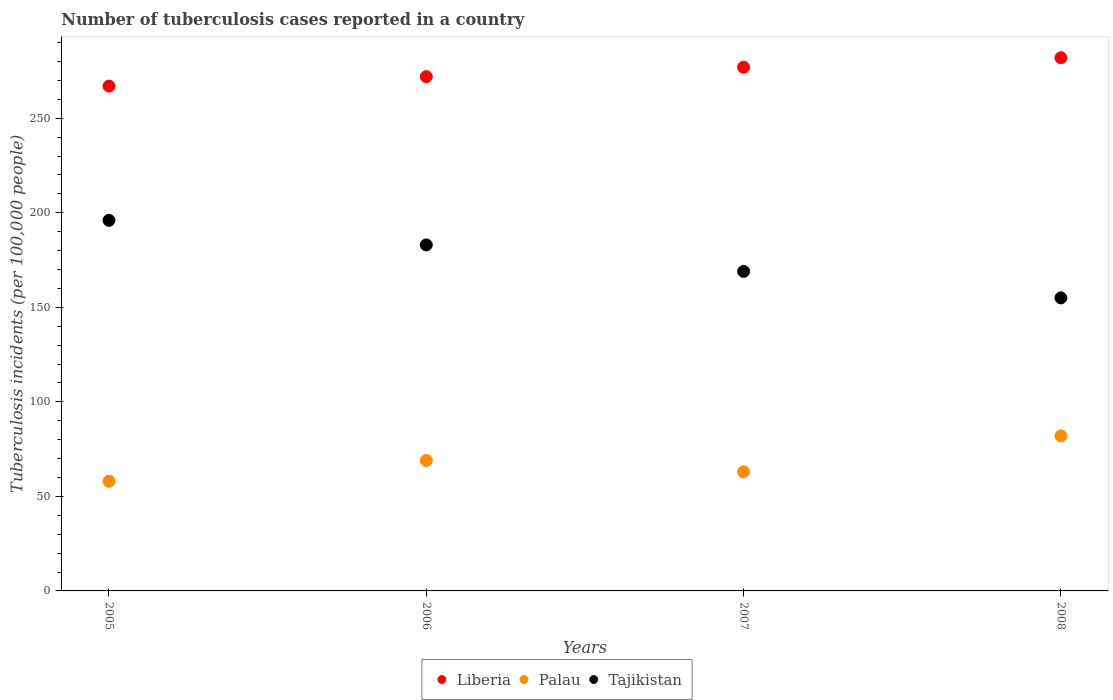Is the number of dotlines equal to the number of legend labels?
Your answer should be very brief. Yes. What is the number of tuberculosis cases reported in in Tajikistan in 2008?
Your answer should be very brief. 155. Across all years, what is the maximum number of tuberculosis cases reported in in Tajikistan?
Make the answer very short. 196. Across all years, what is the minimum number of tuberculosis cases reported in in Tajikistan?
Ensure brevity in your answer.  155. In which year was the number of tuberculosis cases reported in in Tajikistan maximum?
Your response must be concise. 2005. What is the total number of tuberculosis cases reported in in Tajikistan in the graph?
Your response must be concise. 703. What is the difference between the number of tuberculosis cases reported in in Liberia in 2005 and that in 2007?
Your answer should be compact. -10. What is the difference between the number of tuberculosis cases reported in in Liberia in 2006 and the number of tuberculosis cases reported in in Tajikistan in 2007?
Your answer should be compact. 103. What is the average number of tuberculosis cases reported in in Tajikistan per year?
Give a very brief answer. 175.75. In the year 2006, what is the difference between the number of tuberculosis cases reported in in Palau and number of tuberculosis cases reported in in Tajikistan?
Your answer should be very brief. -114. What is the ratio of the number of tuberculosis cases reported in in Liberia in 2005 to that in 2007?
Your response must be concise. 0.96. Is the number of tuberculosis cases reported in in Palau in 2006 less than that in 2007?
Your answer should be compact. No. What is the difference between the highest and the lowest number of tuberculosis cases reported in in Palau?
Your answer should be compact. 24. What is the difference between two consecutive major ticks on the Y-axis?
Keep it short and to the point. 50. Does the graph contain grids?
Your answer should be very brief. No. Where does the legend appear in the graph?
Offer a very short reply. Bottom center. How many legend labels are there?
Offer a terse response. 3. How are the legend labels stacked?
Ensure brevity in your answer.  Horizontal. What is the title of the graph?
Provide a succinct answer. Number of tuberculosis cases reported in a country. Does "Burkina Faso" appear as one of the legend labels in the graph?
Offer a terse response. No. What is the label or title of the X-axis?
Provide a short and direct response. Years. What is the label or title of the Y-axis?
Give a very brief answer. Tuberculosis incidents (per 100,0 people). What is the Tuberculosis incidents (per 100,000 people) in Liberia in 2005?
Give a very brief answer. 267. What is the Tuberculosis incidents (per 100,000 people) of Palau in 2005?
Offer a very short reply. 58. What is the Tuberculosis incidents (per 100,000 people) of Tajikistan in 2005?
Your answer should be compact. 196. What is the Tuberculosis incidents (per 100,000 people) in Liberia in 2006?
Make the answer very short. 272. What is the Tuberculosis incidents (per 100,000 people) in Tajikistan in 2006?
Offer a terse response. 183. What is the Tuberculosis incidents (per 100,000 people) of Liberia in 2007?
Your response must be concise. 277. What is the Tuberculosis incidents (per 100,000 people) in Palau in 2007?
Offer a very short reply. 63. What is the Tuberculosis incidents (per 100,000 people) in Tajikistan in 2007?
Provide a short and direct response. 169. What is the Tuberculosis incidents (per 100,000 people) in Liberia in 2008?
Your answer should be compact. 282. What is the Tuberculosis incidents (per 100,000 people) in Tajikistan in 2008?
Ensure brevity in your answer.  155. Across all years, what is the maximum Tuberculosis incidents (per 100,000 people) of Liberia?
Offer a terse response. 282. Across all years, what is the maximum Tuberculosis incidents (per 100,000 people) of Palau?
Offer a terse response. 82. Across all years, what is the maximum Tuberculosis incidents (per 100,000 people) of Tajikistan?
Provide a short and direct response. 196. Across all years, what is the minimum Tuberculosis incidents (per 100,000 people) of Liberia?
Keep it short and to the point. 267. Across all years, what is the minimum Tuberculosis incidents (per 100,000 people) of Tajikistan?
Your answer should be compact. 155. What is the total Tuberculosis incidents (per 100,000 people) in Liberia in the graph?
Your answer should be compact. 1098. What is the total Tuberculosis incidents (per 100,000 people) of Palau in the graph?
Provide a succinct answer. 272. What is the total Tuberculosis incidents (per 100,000 people) in Tajikistan in the graph?
Your answer should be very brief. 703. What is the difference between the Tuberculosis incidents (per 100,000 people) of Liberia in 2005 and that in 2008?
Your answer should be compact. -15. What is the difference between the Tuberculosis incidents (per 100,000 people) of Tajikistan in 2005 and that in 2008?
Give a very brief answer. 41. What is the difference between the Tuberculosis incidents (per 100,000 people) in Palau in 2006 and that in 2007?
Keep it short and to the point. 6. What is the difference between the Tuberculosis incidents (per 100,000 people) of Tajikistan in 2006 and that in 2007?
Ensure brevity in your answer.  14. What is the difference between the Tuberculosis incidents (per 100,000 people) of Liberia in 2006 and that in 2008?
Your response must be concise. -10. What is the difference between the Tuberculosis incidents (per 100,000 people) in Palau in 2006 and that in 2008?
Provide a succinct answer. -13. What is the difference between the Tuberculosis incidents (per 100,000 people) in Palau in 2007 and that in 2008?
Provide a succinct answer. -19. What is the difference between the Tuberculosis incidents (per 100,000 people) in Tajikistan in 2007 and that in 2008?
Your answer should be very brief. 14. What is the difference between the Tuberculosis incidents (per 100,000 people) of Liberia in 2005 and the Tuberculosis incidents (per 100,000 people) of Palau in 2006?
Provide a short and direct response. 198. What is the difference between the Tuberculosis incidents (per 100,000 people) in Palau in 2005 and the Tuberculosis incidents (per 100,000 people) in Tajikistan in 2006?
Your answer should be very brief. -125. What is the difference between the Tuberculosis incidents (per 100,000 people) in Liberia in 2005 and the Tuberculosis incidents (per 100,000 people) in Palau in 2007?
Your response must be concise. 204. What is the difference between the Tuberculosis incidents (per 100,000 people) of Liberia in 2005 and the Tuberculosis incidents (per 100,000 people) of Tajikistan in 2007?
Your answer should be compact. 98. What is the difference between the Tuberculosis incidents (per 100,000 people) of Palau in 2005 and the Tuberculosis incidents (per 100,000 people) of Tajikistan in 2007?
Provide a succinct answer. -111. What is the difference between the Tuberculosis incidents (per 100,000 people) of Liberia in 2005 and the Tuberculosis incidents (per 100,000 people) of Palau in 2008?
Ensure brevity in your answer.  185. What is the difference between the Tuberculosis incidents (per 100,000 people) in Liberia in 2005 and the Tuberculosis incidents (per 100,000 people) in Tajikistan in 2008?
Make the answer very short. 112. What is the difference between the Tuberculosis incidents (per 100,000 people) of Palau in 2005 and the Tuberculosis incidents (per 100,000 people) of Tajikistan in 2008?
Give a very brief answer. -97. What is the difference between the Tuberculosis incidents (per 100,000 people) in Liberia in 2006 and the Tuberculosis incidents (per 100,000 people) in Palau in 2007?
Your answer should be compact. 209. What is the difference between the Tuberculosis incidents (per 100,000 people) of Liberia in 2006 and the Tuberculosis incidents (per 100,000 people) of Tajikistan in 2007?
Offer a terse response. 103. What is the difference between the Tuberculosis incidents (per 100,000 people) in Palau in 2006 and the Tuberculosis incidents (per 100,000 people) in Tajikistan in 2007?
Your answer should be very brief. -100. What is the difference between the Tuberculosis incidents (per 100,000 people) in Liberia in 2006 and the Tuberculosis incidents (per 100,000 people) in Palau in 2008?
Offer a very short reply. 190. What is the difference between the Tuberculosis incidents (per 100,000 people) of Liberia in 2006 and the Tuberculosis incidents (per 100,000 people) of Tajikistan in 2008?
Ensure brevity in your answer.  117. What is the difference between the Tuberculosis incidents (per 100,000 people) in Palau in 2006 and the Tuberculosis incidents (per 100,000 people) in Tajikistan in 2008?
Provide a succinct answer. -86. What is the difference between the Tuberculosis incidents (per 100,000 people) in Liberia in 2007 and the Tuberculosis incidents (per 100,000 people) in Palau in 2008?
Offer a terse response. 195. What is the difference between the Tuberculosis incidents (per 100,000 people) of Liberia in 2007 and the Tuberculosis incidents (per 100,000 people) of Tajikistan in 2008?
Give a very brief answer. 122. What is the difference between the Tuberculosis incidents (per 100,000 people) in Palau in 2007 and the Tuberculosis incidents (per 100,000 people) in Tajikistan in 2008?
Keep it short and to the point. -92. What is the average Tuberculosis incidents (per 100,000 people) in Liberia per year?
Your answer should be very brief. 274.5. What is the average Tuberculosis incidents (per 100,000 people) of Tajikistan per year?
Your answer should be very brief. 175.75. In the year 2005, what is the difference between the Tuberculosis incidents (per 100,000 people) of Liberia and Tuberculosis incidents (per 100,000 people) of Palau?
Ensure brevity in your answer.  209. In the year 2005, what is the difference between the Tuberculosis incidents (per 100,000 people) in Liberia and Tuberculosis incidents (per 100,000 people) in Tajikistan?
Offer a very short reply. 71. In the year 2005, what is the difference between the Tuberculosis incidents (per 100,000 people) of Palau and Tuberculosis incidents (per 100,000 people) of Tajikistan?
Provide a short and direct response. -138. In the year 2006, what is the difference between the Tuberculosis incidents (per 100,000 people) of Liberia and Tuberculosis incidents (per 100,000 people) of Palau?
Give a very brief answer. 203. In the year 2006, what is the difference between the Tuberculosis incidents (per 100,000 people) of Liberia and Tuberculosis incidents (per 100,000 people) of Tajikistan?
Your answer should be compact. 89. In the year 2006, what is the difference between the Tuberculosis incidents (per 100,000 people) in Palau and Tuberculosis incidents (per 100,000 people) in Tajikistan?
Your answer should be very brief. -114. In the year 2007, what is the difference between the Tuberculosis incidents (per 100,000 people) in Liberia and Tuberculosis incidents (per 100,000 people) in Palau?
Your answer should be compact. 214. In the year 2007, what is the difference between the Tuberculosis incidents (per 100,000 people) of Liberia and Tuberculosis incidents (per 100,000 people) of Tajikistan?
Your response must be concise. 108. In the year 2007, what is the difference between the Tuberculosis incidents (per 100,000 people) in Palau and Tuberculosis incidents (per 100,000 people) in Tajikistan?
Give a very brief answer. -106. In the year 2008, what is the difference between the Tuberculosis incidents (per 100,000 people) of Liberia and Tuberculosis incidents (per 100,000 people) of Tajikistan?
Your response must be concise. 127. In the year 2008, what is the difference between the Tuberculosis incidents (per 100,000 people) of Palau and Tuberculosis incidents (per 100,000 people) of Tajikistan?
Offer a terse response. -73. What is the ratio of the Tuberculosis incidents (per 100,000 people) in Liberia in 2005 to that in 2006?
Offer a terse response. 0.98. What is the ratio of the Tuberculosis incidents (per 100,000 people) in Palau in 2005 to that in 2006?
Offer a terse response. 0.84. What is the ratio of the Tuberculosis incidents (per 100,000 people) in Tajikistan in 2005 to that in 2006?
Your answer should be compact. 1.07. What is the ratio of the Tuberculosis incidents (per 100,000 people) of Liberia in 2005 to that in 2007?
Your answer should be compact. 0.96. What is the ratio of the Tuberculosis incidents (per 100,000 people) in Palau in 2005 to that in 2007?
Offer a terse response. 0.92. What is the ratio of the Tuberculosis incidents (per 100,000 people) in Tajikistan in 2005 to that in 2007?
Provide a succinct answer. 1.16. What is the ratio of the Tuberculosis incidents (per 100,000 people) in Liberia in 2005 to that in 2008?
Keep it short and to the point. 0.95. What is the ratio of the Tuberculosis incidents (per 100,000 people) in Palau in 2005 to that in 2008?
Offer a very short reply. 0.71. What is the ratio of the Tuberculosis incidents (per 100,000 people) of Tajikistan in 2005 to that in 2008?
Provide a succinct answer. 1.26. What is the ratio of the Tuberculosis incidents (per 100,000 people) of Liberia in 2006 to that in 2007?
Your response must be concise. 0.98. What is the ratio of the Tuberculosis incidents (per 100,000 people) in Palau in 2006 to that in 2007?
Keep it short and to the point. 1.1. What is the ratio of the Tuberculosis incidents (per 100,000 people) of Tajikistan in 2006 to that in 2007?
Keep it short and to the point. 1.08. What is the ratio of the Tuberculosis incidents (per 100,000 people) in Liberia in 2006 to that in 2008?
Your answer should be compact. 0.96. What is the ratio of the Tuberculosis incidents (per 100,000 people) of Palau in 2006 to that in 2008?
Keep it short and to the point. 0.84. What is the ratio of the Tuberculosis incidents (per 100,000 people) of Tajikistan in 2006 to that in 2008?
Offer a very short reply. 1.18. What is the ratio of the Tuberculosis incidents (per 100,000 people) in Liberia in 2007 to that in 2008?
Keep it short and to the point. 0.98. What is the ratio of the Tuberculosis incidents (per 100,000 people) in Palau in 2007 to that in 2008?
Provide a short and direct response. 0.77. What is the ratio of the Tuberculosis incidents (per 100,000 people) of Tajikistan in 2007 to that in 2008?
Ensure brevity in your answer.  1.09. What is the difference between the highest and the second highest Tuberculosis incidents (per 100,000 people) in Tajikistan?
Ensure brevity in your answer.  13. What is the difference between the highest and the lowest Tuberculosis incidents (per 100,000 people) in Liberia?
Give a very brief answer. 15. 